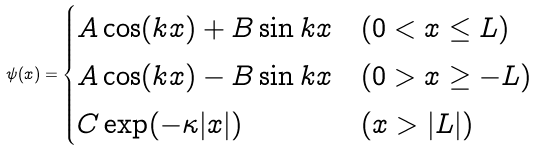<formula> <loc_0><loc_0><loc_500><loc_500>\psi ( x ) = \begin{cases} A \cos ( k x ) + B \sin k x & ( 0 < x \leq L ) \\ A \cos ( k x ) - B \sin k x & ( 0 > x \geq - L ) \\ C \exp ( - \kappa | x | ) \quad & ( x > | L | ) \end{cases}</formula> 